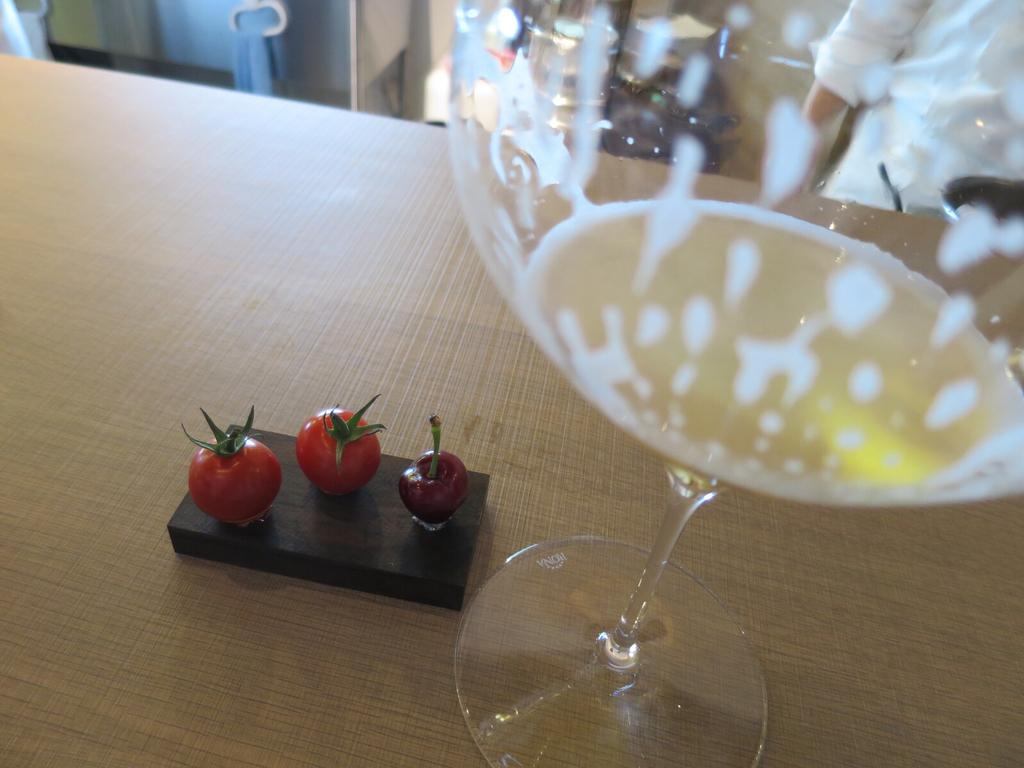What type of table is in the image? There is a brown table in the image. What is placed on the table? There are three strawberries and a glass on the table. Where is the basket located during the meeting in the image? There is no basket or meeting present in the image. 